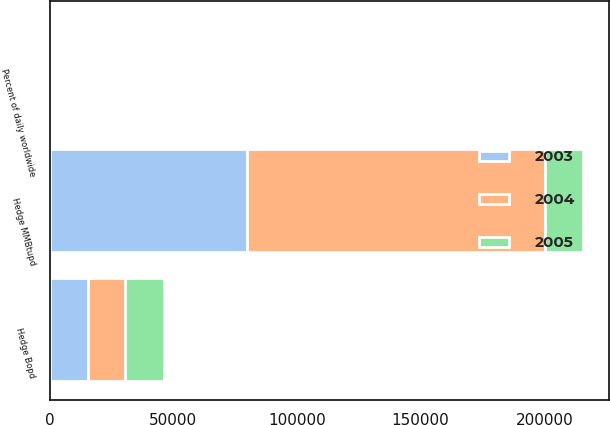Convert chart to OTSL. <chart><loc_0><loc_0><loc_500><loc_500><stacked_bar_chart><ecel><fcel>Hedge MMBtupd<fcel>Percent of daily worldwide<fcel>Hedge Bopd<nl><fcel>2003<fcel>79932<fcel>16<fcel>15519<nl><fcel>2004<fcel>120284<fcel>33<fcel>15005<nl><fcel>2005<fcel>15262<fcel>56<fcel>15793<nl></chart> 